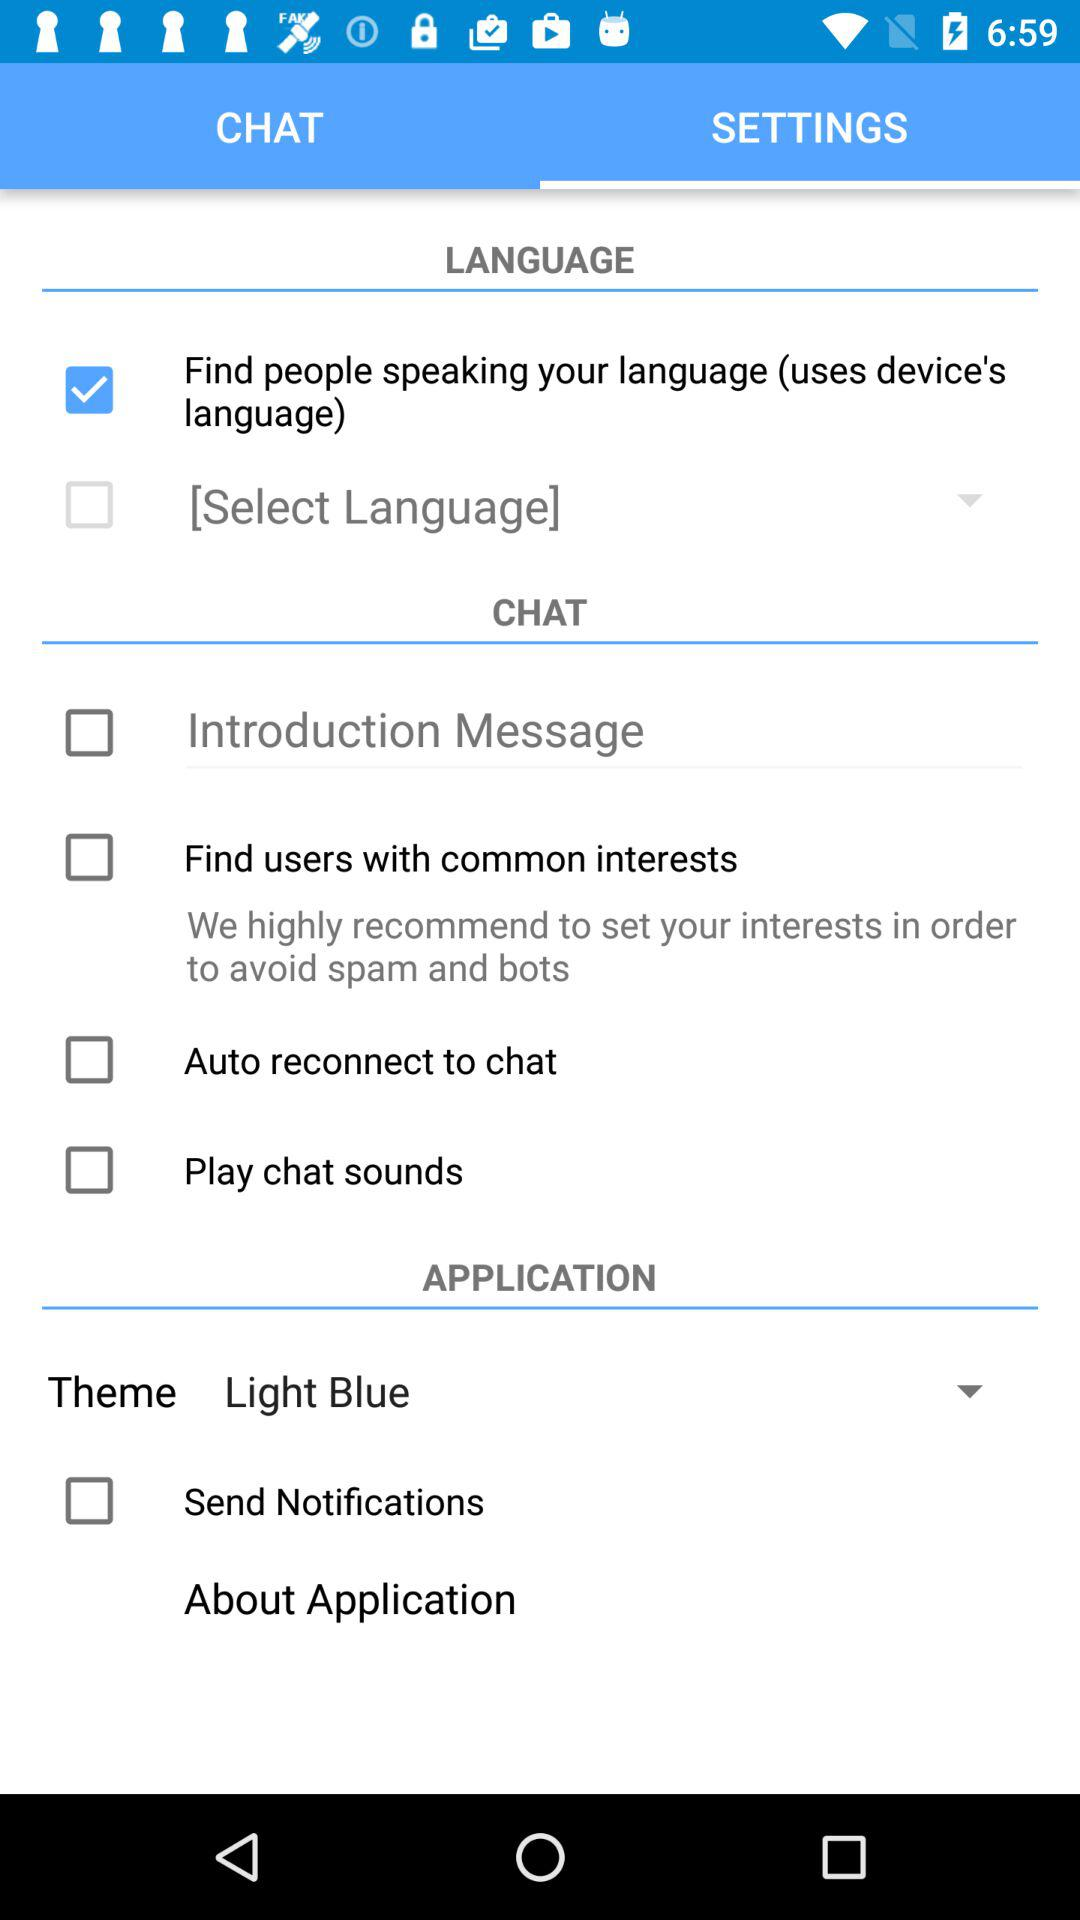Which tab are we on? You are on the "SETTINGS" tab. 